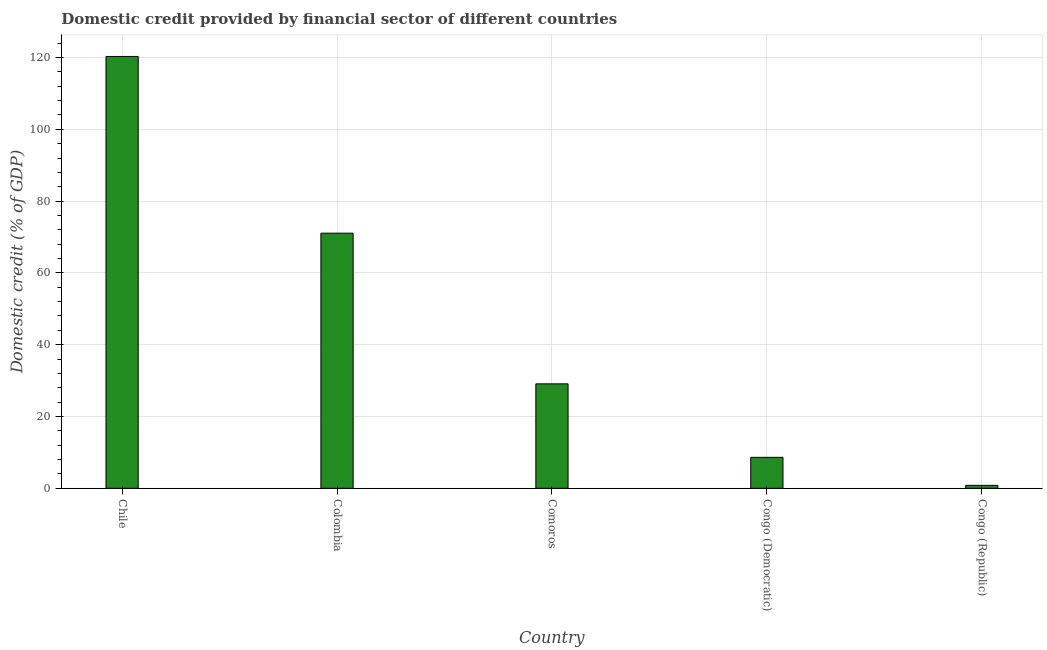What is the title of the graph?
Your response must be concise. Domestic credit provided by financial sector of different countries. What is the label or title of the X-axis?
Ensure brevity in your answer.  Country. What is the label or title of the Y-axis?
Your answer should be compact. Domestic credit (% of GDP). What is the domestic credit provided by financial sector in Congo (Democratic)?
Keep it short and to the point. 8.62. Across all countries, what is the maximum domestic credit provided by financial sector?
Provide a short and direct response. 120.28. Across all countries, what is the minimum domestic credit provided by financial sector?
Your answer should be compact. 0.81. In which country was the domestic credit provided by financial sector minimum?
Your response must be concise. Congo (Republic). What is the sum of the domestic credit provided by financial sector?
Give a very brief answer. 229.87. What is the difference between the domestic credit provided by financial sector in Colombia and Congo (Democratic)?
Your response must be concise. 62.44. What is the average domestic credit provided by financial sector per country?
Make the answer very short. 45.97. What is the median domestic credit provided by financial sector?
Your response must be concise. 29.09. What is the ratio of the domestic credit provided by financial sector in Congo (Democratic) to that in Congo (Republic)?
Make the answer very short. 10.59. Is the difference between the domestic credit provided by financial sector in Colombia and Comoros greater than the difference between any two countries?
Make the answer very short. No. What is the difference between the highest and the second highest domestic credit provided by financial sector?
Give a very brief answer. 49.22. What is the difference between the highest and the lowest domestic credit provided by financial sector?
Your answer should be very brief. 119.47. How many bars are there?
Provide a succinct answer. 5. How many countries are there in the graph?
Offer a very short reply. 5. What is the difference between two consecutive major ticks on the Y-axis?
Your response must be concise. 20. Are the values on the major ticks of Y-axis written in scientific E-notation?
Give a very brief answer. No. What is the Domestic credit (% of GDP) of Chile?
Your answer should be compact. 120.28. What is the Domestic credit (% of GDP) of Colombia?
Offer a terse response. 71.06. What is the Domestic credit (% of GDP) in Comoros?
Ensure brevity in your answer.  29.09. What is the Domestic credit (% of GDP) of Congo (Democratic)?
Offer a very short reply. 8.62. What is the Domestic credit (% of GDP) in Congo (Republic)?
Your answer should be very brief. 0.81. What is the difference between the Domestic credit (% of GDP) in Chile and Colombia?
Keep it short and to the point. 49.22. What is the difference between the Domestic credit (% of GDP) in Chile and Comoros?
Provide a succinct answer. 91.2. What is the difference between the Domestic credit (% of GDP) in Chile and Congo (Democratic)?
Provide a succinct answer. 111.66. What is the difference between the Domestic credit (% of GDP) in Chile and Congo (Republic)?
Your response must be concise. 119.47. What is the difference between the Domestic credit (% of GDP) in Colombia and Comoros?
Provide a succinct answer. 41.97. What is the difference between the Domestic credit (% of GDP) in Colombia and Congo (Democratic)?
Offer a very short reply. 62.44. What is the difference between the Domestic credit (% of GDP) in Colombia and Congo (Republic)?
Keep it short and to the point. 70.24. What is the difference between the Domestic credit (% of GDP) in Comoros and Congo (Democratic)?
Give a very brief answer. 20.47. What is the difference between the Domestic credit (% of GDP) in Comoros and Congo (Republic)?
Your answer should be compact. 28.27. What is the difference between the Domestic credit (% of GDP) in Congo (Democratic) and Congo (Republic)?
Ensure brevity in your answer.  7.81. What is the ratio of the Domestic credit (% of GDP) in Chile to that in Colombia?
Make the answer very short. 1.69. What is the ratio of the Domestic credit (% of GDP) in Chile to that in Comoros?
Your answer should be compact. 4.13. What is the ratio of the Domestic credit (% of GDP) in Chile to that in Congo (Democratic)?
Make the answer very short. 13.95. What is the ratio of the Domestic credit (% of GDP) in Chile to that in Congo (Republic)?
Make the answer very short. 147.68. What is the ratio of the Domestic credit (% of GDP) in Colombia to that in Comoros?
Ensure brevity in your answer.  2.44. What is the ratio of the Domestic credit (% of GDP) in Colombia to that in Congo (Democratic)?
Your response must be concise. 8.24. What is the ratio of the Domestic credit (% of GDP) in Colombia to that in Congo (Republic)?
Offer a terse response. 87.24. What is the ratio of the Domestic credit (% of GDP) in Comoros to that in Congo (Democratic)?
Offer a terse response. 3.37. What is the ratio of the Domestic credit (% of GDP) in Comoros to that in Congo (Republic)?
Ensure brevity in your answer.  35.71. What is the ratio of the Domestic credit (% of GDP) in Congo (Democratic) to that in Congo (Republic)?
Ensure brevity in your answer.  10.59. 